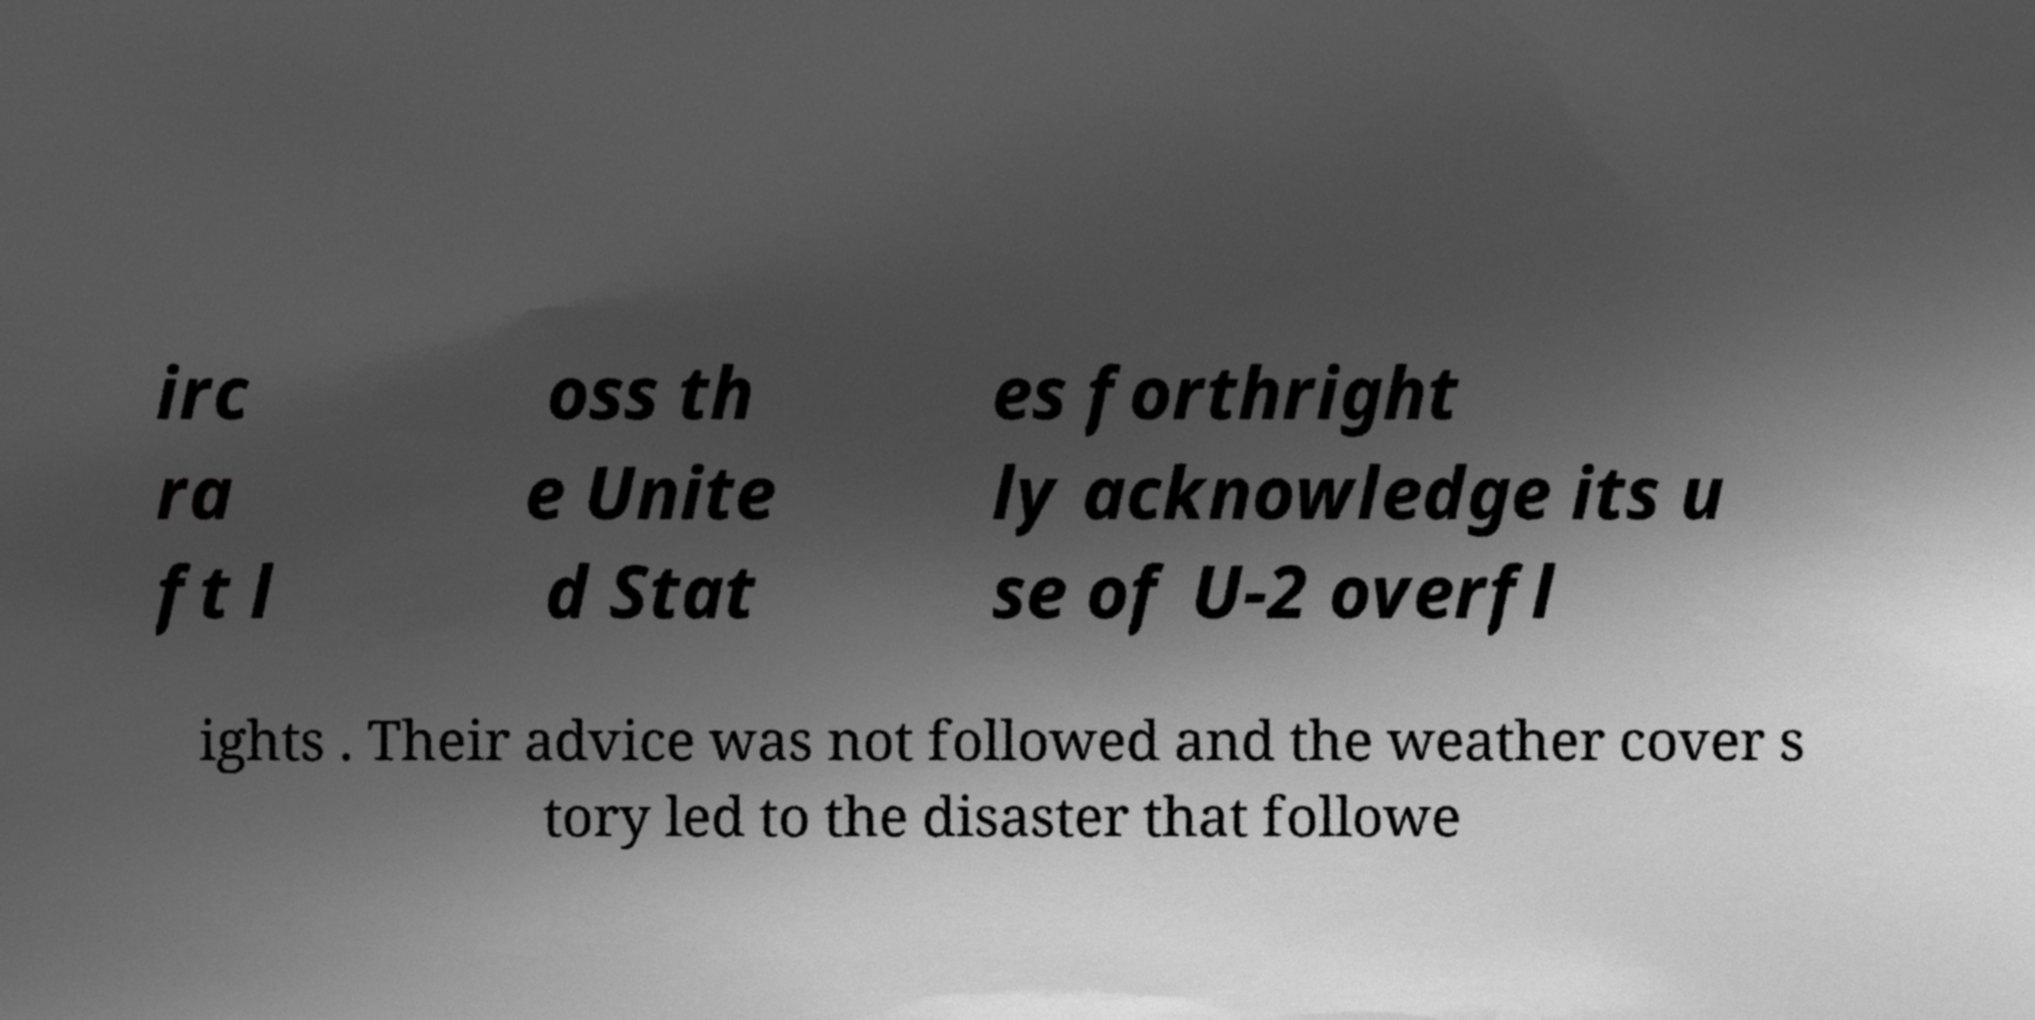What messages or text are displayed in this image? I need them in a readable, typed format. irc ra ft l oss th e Unite d Stat es forthright ly acknowledge its u se of U-2 overfl ights . Their advice was not followed and the weather cover s tory led to the disaster that followe 